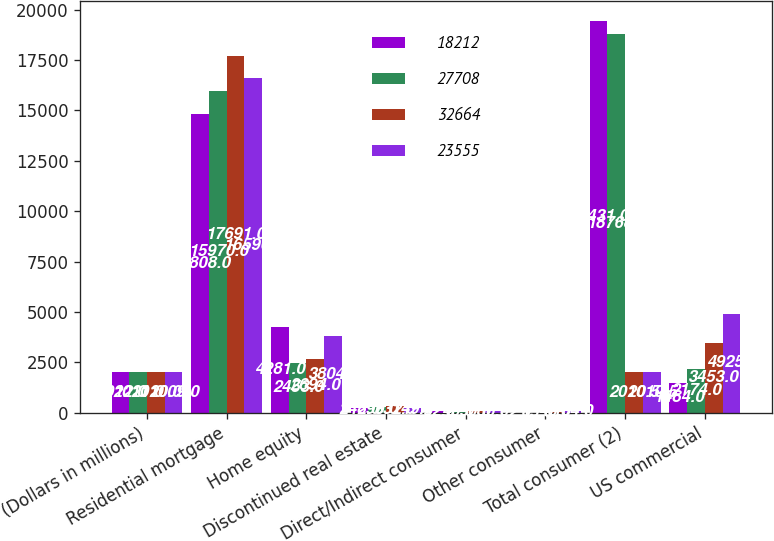<chart> <loc_0><loc_0><loc_500><loc_500><stacked_bar_chart><ecel><fcel>(Dollars in millions)<fcel>Residential mortgage<fcel>Home equity<fcel>Discontinued real estate<fcel>Direct/Indirect consumer<fcel>Other consumer<fcel>Total consumer (2)<fcel>US commercial<nl><fcel>18212<fcel>2012<fcel>14808<fcel>4281<fcel>248<fcel>92<fcel>2<fcel>19431<fcel>1484<nl><fcel>27708<fcel>2011<fcel>15970<fcel>2453<fcel>290<fcel>40<fcel>15<fcel>18768<fcel>2174<nl><fcel>32664<fcel>2010<fcel>17691<fcel>2694<fcel>331<fcel>90<fcel>48<fcel>2010.5<fcel>3453<nl><fcel>23555<fcel>2009<fcel>16596<fcel>3804<fcel>249<fcel>86<fcel>104<fcel>2010.5<fcel>4925<nl></chart> 